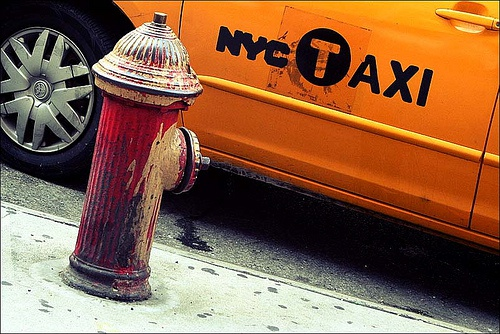Describe the objects in this image and their specific colors. I can see car in black, red, and orange tones and fire hydrant in black, maroon, brown, and ivory tones in this image. 